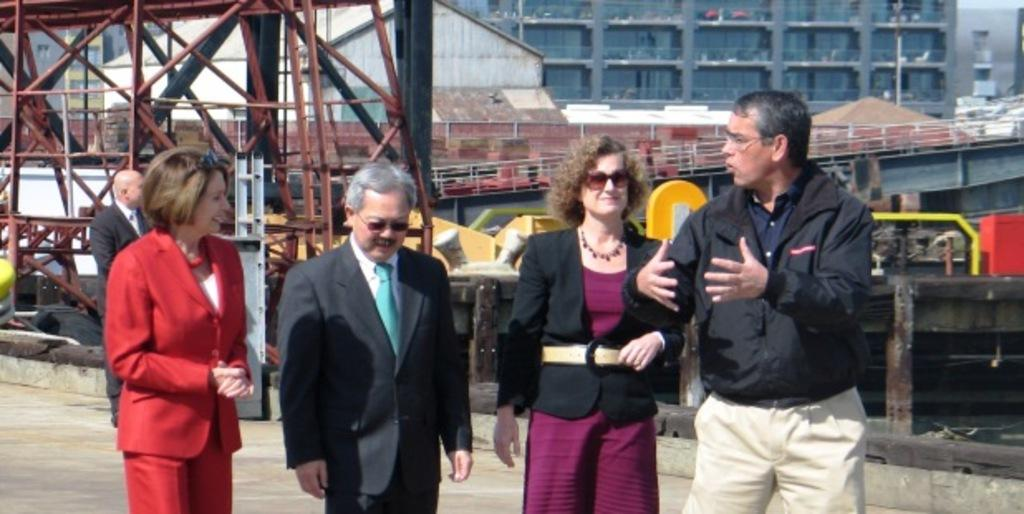How many people are visible in the image? There are five people visible in the image. Can you describe the positions of the people in the image? Four persons are standing in the image, and there is another person standing behind them. What can be seen in the background of the image? There is a building and other objects in the background of the image. How many spiders are crawling on the person standing behind the group? There are no spiders visible in the image, so it cannot be determined how many might be crawling on any person. What is the occupation of the maid in the image? There is no maid present in the image. 